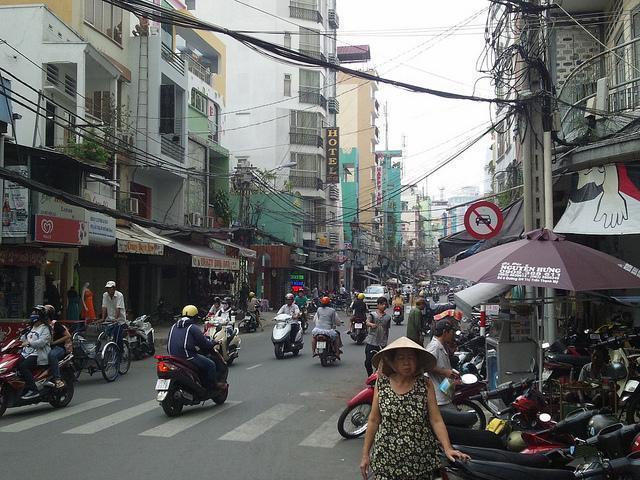Why is the woman wearing a triangular hat?
Select the accurate answer and provide justification: `Answer: choice
Rationale: srationale.`
Options: Dress code, visibility, protection, camouflage. Answer: protection.
Rationale: Her hat will keep the sun off her face and out of her eyes. 